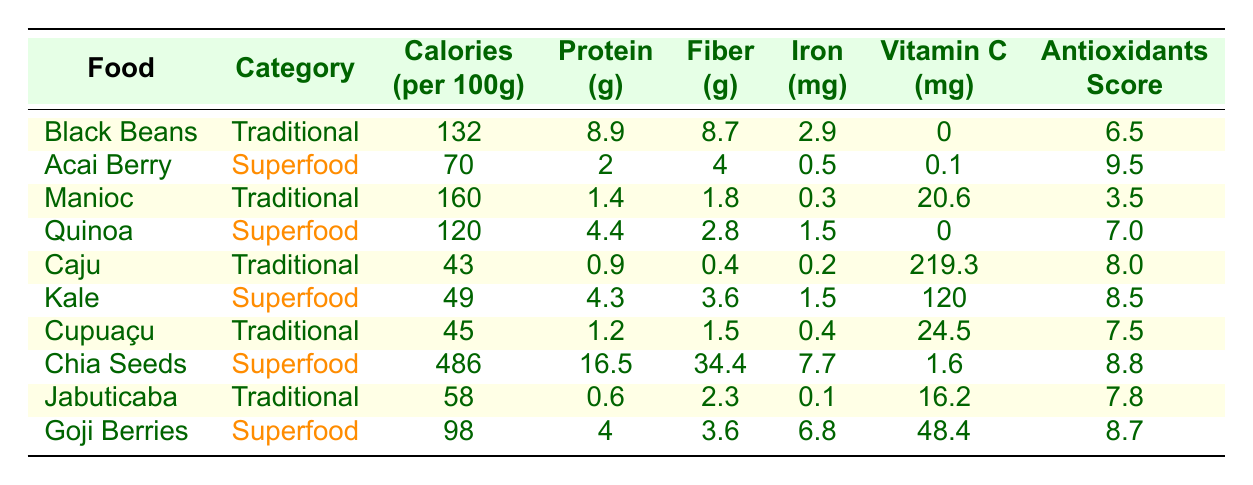What is the protein content in Black Beans? The table lists Black Beans as having a protein content of 8.9 grams per 100 grams. This value can be found directly in the 'Protein (g)' column corresponding to Black Beans.
Answer: 8.9 grams Which food has the highest vitamin C content? Looking at the table, the food with the highest vitamin C content is Caju (Cashew Fruit), with 219.3 mg per 100g. This is clearly indicated in the 'Vitamin C (mg)' column.
Answer: Caju (Cashew Fruit) What is the difference in calories between Chia Seeds and Acai Berry? Chia Seeds have 486 calories per 100g, while Acai Berry has 70 calories per 100g. The difference is calculated as 486 - 70 = 416 calories.
Answer: 416 calories Is Kale considered a traditional Brazilian food? The table categorizes Kale as a "Superfood," not as a traditional Brazilian food. Therefore, the statement is false.
Answer: No What is the average fiber content of Traditional Brazilian foods listed in the table? The fiber content for Traditional Brazilian foods are: Black Beans (8.7g), Manioc (1.8g), Caju (0.4g), Cupuaçu (1.5g), and Jabuticaba (2.3g). Adding these values gives 8.7 + 1.8 + 0.4 + 1.5 + 2.3 = 14.7g. Dividing by the number of Traditional foods (5) gives an average of 14.7g / 5 = 2.94g.
Answer: 2.94 grams Which superfood has the lowest iron content? The table shows that Acai Berry contains only 0.5 mg of iron per 100g, which is lower than all the other superfoods listed. This information can be quickly verified by comparing the 'Iron (mg)' column for each superfood.
Answer: Acai Berry How does the antioxidants score of Cupuaçu compare to that of Quinoa? Cupuaçu has an antioxidants score of 7.5, while Quinoa has a score of 7.0. Comparing the two shows that Cupuaçu's score is higher by 7.5 - 7.0 = 0.5.
Answer: Cupuaçu has a higher score by 0.5 Is the protein content in Goji Berries more than that in Caju? Goji Berries contain 4 grams of protein, while Caju contains 0.9 grams. Since 4 is greater than 0.9, the statement is true.
Answer: Yes What is the combined fiber content of all superfoods listed in the table? The fiber contents for the superfoods are: Acai Berry (4g), Quinoa (2.8g), Kale (3.6g), Chia Seeds (34.4g), and Goji Berries (3.6g). Adding these values gives 4 + 2.8 + 3.6 + 34.4 + 3.6 = 48.4g.
Answer: 48.4 grams 